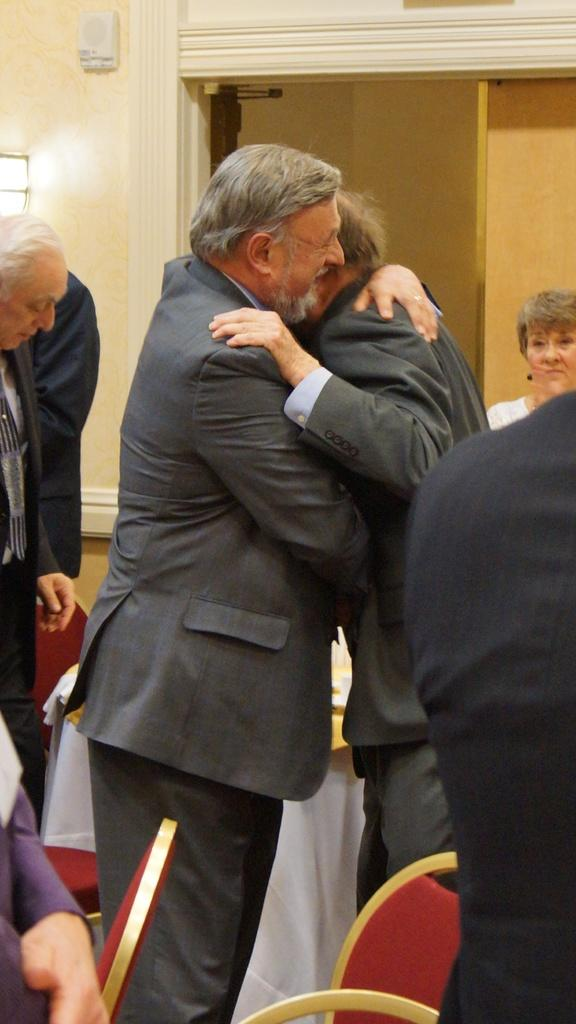How many people are in the image? There are people in the image, specifically two men who are standing and hugging each other. What are the men in the image doing? The two men in the image are standing and hugging each other. Can you describe any objects or features in the background? There may be a light on the wall in the background. What type of furniture is present in the image? There are chairs in the image. Is there a tank visible in the image? No, there is no tank present in the image. Can you see a volcano erupting in the background of the image? No, there is no volcano present in the image. 